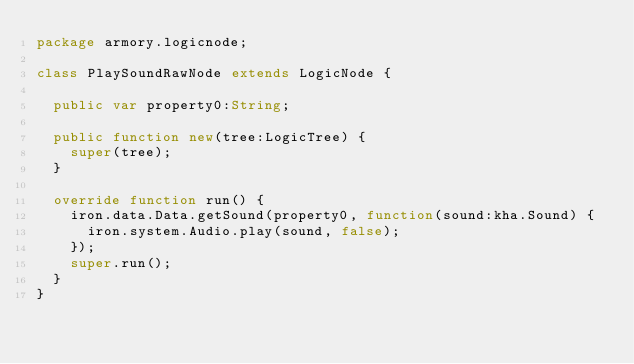<code> <loc_0><loc_0><loc_500><loc_500><_Haxe_>package armory.logicnode;

class PlaySoundRawNode extends LogicNode {

	public var property0:String;

	public function new(tree:LogicTree) {
		super(tree);
	}

	override function run() {
		iron.data.Data.getSound(property0, function(sound:kha.Sound) {
			iron.system.Audio.play(sound, false);
		});
		super.run();
	}
}
</code> 